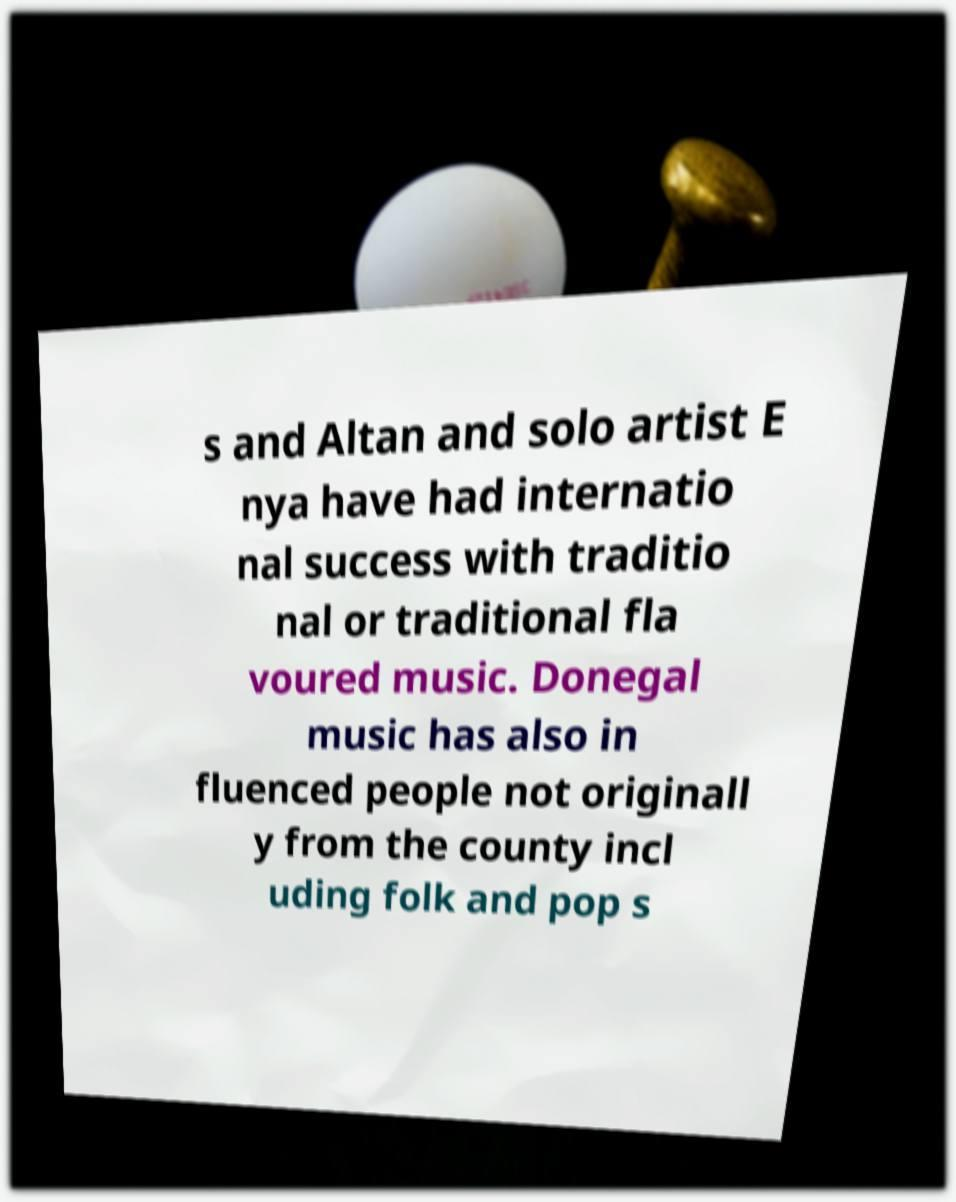Please identify and transcribe the text found in this image. s and Altan and solo artist E nya have had internatio nal success with traditio nal or traditional fla voured music. Donegal music has also in fluenced people not originall y from the county incl uding folk and pop s 